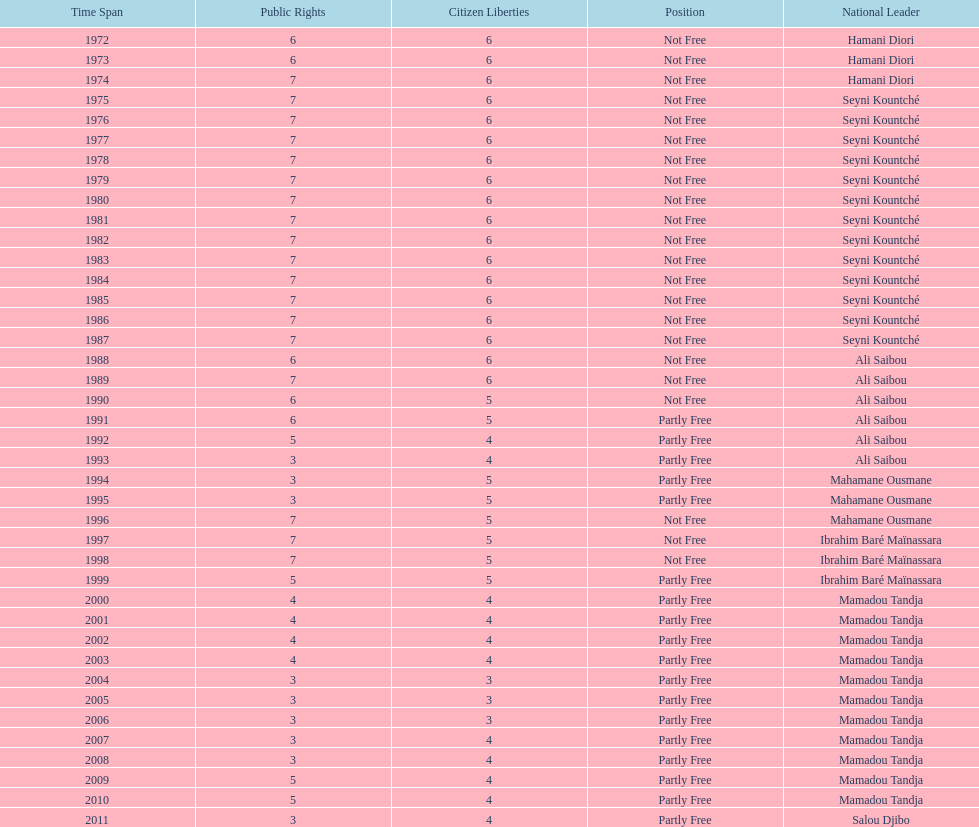Who ruled longer, ali saibou or mamadou tandja? Mamadou Tandja. 